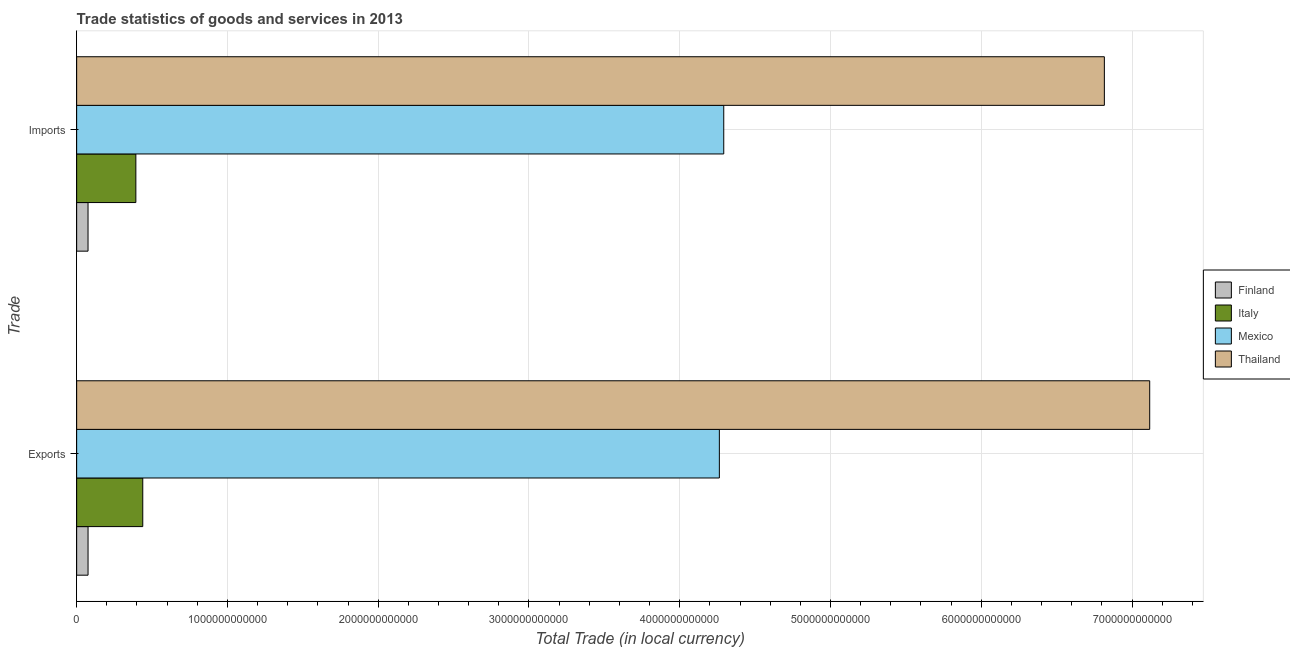How many groups of bars are there?
Make the answer very short. 2. Are the number of bars per tick equal to the number of legend labels?
Offer a terse response. Yes. Are the number of bars on each tick of the Y-axis equal?
Give a very brief answer. Yes. How many bars are there on the 2nd tick from the bottom?
Give a very brief answer. 4. What is the label of the 1st group of bars from the top?
Keep it short and to the point. Imports. What is the export of goods and services in Italy?
Your response must be concise. 4.38e+11. Across all countries, what is the maximum imports of goods and services?
Your response must be concise. 6.82e+12. Across all countries, what is the minimum export of goods and services?
Keep it short and to the point. 7.56e+1. In which country was the imports of goods and services maximum?
Your answer should be very brief. Thailand. What is the total export of goods and services in the graph?
Your answer should be very brief. 1.19e+13. What is the difference between the export of goods and services in Mexico and that in Finland?
Keep it short and to the point. 4.19e+12. What is the difference between the imports of goods and services in Finland and the export of goods and services in Italy?
Offer a terse response. -3.63e+11. What is the average imports of goods and services per country?
Your response must be concise. 2.89e+12. What is the difference between the imports of goods and services and export of goods and services in Italy?
Provide a short and direct response. -4.58e+1. What is the ratio of the export of goods and services in Mexico to that in Italy?
Make the answer very short. 9.72. Is the export of goods and services in Italy less than that in Mexico?
Your answer should be compact. Yes. In how many countries, is the imports of goods and services greater than the average imports of goods and services taken over all countries?
Offer a terse response. 2. What does the 3rd bar from the top in Imports represents?
Make the answer very short. Italy. What does the 3rd bar from the bottom in Exports represents?
Keep it short and to the point. Mexico. How many bars are there?
Give a very brief answer. 8. How many countries are there in the graph?
Keep it short and to the point. 4. What is the difference between two consecutive major ticks on the X-axis?
Your answer should be very brief. 1.00e+12. How many legend labels are there?
Offer a terse response. 4. What is the title of the graph?
Your answer should be compact. Trade statistics of goods and services in 2013. What is the label or title of the X-axis?
Your answer should be very brief. Total Trade (in local currency). What is the label or title of the Y-axis?
Offer a very short reply. Trade. What is the Total Trade (in local currency) of Finland in Exports?
Your answer should be very brief. 7.56e+1. What is the Total Trade (in local currency) in Italy in Exports?
Make the answer very short. 4.38e+11. What is the Total Trade (in local currency) in Mexico in Exports?
Ensure brevity in your answer.  4.26e+12. What is the Total Trade (in local currency) of Thailand in Exports?
Provide a short and direct response. 7.12e+12. What is the Total Trade (in local currency) of Finland in Imports?
Your response must be concise. 7.55e+1. What is the Total Trade (in local currency) of Italy in Imports?
Offer a very short reply. 3.93e+11. What is the Total Trade (in local currency) of Mexico in Imports?
Your response must be concise. 4.29e+12. What is the Total Trade (in local currency) of Thailand in Imports?
Your answer should be very brief. 6.82e+12. Across all Trade, what is the maximum Total Trade (in local currency) in Finland?
Your answer should be very brief. 7.56e+1. Across all Trade, what is the maximum Total Trade (in local currency) in Italy?
Your answer should be very brief. 4.38e+11. Across all Trade, what is the maximum Total Trade (in local currency) in Mexico?
Ensure brevity in your answer.  4.29e+12. Across all Trade, what is the maximum Total Trade (in local currency) in Thailand?
Keep it short and to the point. 7.12e+12. Across all Trade, what is the minimum Total Trade (in local currency) of Finland?
Provide a succinct answer. 7.55e+1. Across all Trade, what is the minimum Total Trade (in local currency) in Italy?
Your response must be concise. 3.93e+11. Across all Trade, what is the minimum Total Trade (in local currency) of Mexico?
Make the answer very short. 4.26e+12. Across all Trade, what is the minimum Total Trade (in local currency) in Thailand?
Offer a very short reply. 6.82e+12. What is the total Total Trade (in local currency) of Finland in the graph?
Provide a succinct answer. 1.51e+11. What is the total Total Trade (in local currency) in Italy in the graph?
Offer a very short reply. 8.31e+11. What is the total Total Trade (in local currency) of Mexico in the graph?
Offer a very short reply. 8.55e+12. What is the total Total Trade (in local currency) of Thailand in the graph?
Make the answer very short. 1.39e+13. What is the difference between the Total Trade (in local currency) in Finland in Exports and that in Imports?
Offer a terse response. 1.14e+08. What is the difference between the Total Trade (in local currency) in Italy in Exports and that in Imports?
Keep it short and to the point. 4.58e+1. What is the difference between the Total Trade (in local currency) in Mexico in Exports and that in Imports?
Offer a terse response. -2.92e+1. What is the difference between the Total Trade (in local currency) of Thailand in Exports and that in Imports?
Make the answer very short. 3.01e+11. What is the difference between the Total Trade (in local currency) of Finland in Exports and the Total Trade (in local currency) of Italy in Imports?
Provide a succinct answer. -3.17e+11. What is the difference between the Total Trade (in local currency) of Finland in Exports and the Total Trade (in local currency) of Mexico in Imports?
Offer a terse response. -4.22e+12. What is the difference between the Total Trade (in local currency) of Finland in Exports and the Total Trade (in local currency) of Thailand in Imports?
Ensure brevity in your answer.  -6.74e+12. What is the difference between the Total Trade (in local currency) of Italy in Exports and the Total Trade (in local currency) of Mexico in Imports?
Keep it short and to the point. -3.85e+12. What is the difference between the Total Trade (in local currency) of Italy in Exports and the Total Trade (in local currency) of Thailand in Imports?
Your response must be concise. -6.38e+12. What is the difference between the Total Trade (in local currency) in Mexico in Exports and the Total Trade (in local currency) in Thailand in Imports?
Your answer should be very brief. -2.55e+12. What is the average Total Trade (in local currency) of Finland per Trade?
Your response must be concise. 7.55e+1. What is the average Total Trade (in local currency) in Italy per Trade?
Offer a terse response. 4.16e+11. What is the average Total Trade (in local currency) of Mexico per Trade?
Provide a succinct answer. 4.28e+12. What is the average Total Trade (in local currency) of Thailand per Trade?
Provide a short and direct response. 6.97e+12. What is the difference between the Total Trade (in local currency) of Finland and Total Trade (in local currency) of Italy in Exports?
Ensure brevity in your answer.  -3.63e+11. What is the difference between the Total Trade (in local currency) in Finland and Total Trade (in local currency) in Mexico in Exports?
Your response must be concise. -4.19e+12. What is the difference between the Total Trade (in local currency) of Finland and Total Trade (in local currency) of Thailand in Exports?
Make the answer very short. -7.04e+12. What is the difference between the Total Trade (in local currency) of Italy and Total Trade (in local currency) of Mexico in Exports?
Offer a very short reply. -3.82e+12. What is the difference between the Total Trade (in local currency) of Italy and Total Trade (in local currency) of Thailand in Exports?
Provide a short and direct response. -6.68e+12. What is the difference between the Total Trade (in local currency) in Mexico and Total Trade (in local currency) in Thailand in Exports?
Offer a terse response. -2.85e+12. What is the difference between the Total Trade (in local currency) of Finland and Total Trade (in local currency) of Italy in Imports?
Offer a very short reply. -3.17e+11. What is the difference between the Total Trade (in local currency) in Finland and Total Trade (in local currency) in Mexico in Imports?
Make the answer very short. -4.22e+12. What is the difference between the Total Trade (in local currency) of Finland and Total Trade (in local currency) of Thailand in Imports?
Keep it short and to the point. -6.74e+12. What is the difference between the Total Trade (in local currency) of Italy and Total Trade (in local currency) of Mexico in Imports?
Your answer should be very brief. -3.90e+12. What is the difference between the Total Trade (in local currency) in Italy and Total Trade (in local currency) in Thailand in Imports?
Offer a terse response. -6.42e+12. What is the difference between the Total Trade (in local currency) of Mexico and Total Trade (in local currency) of Thailand in Imports?
Give a very brief answer. -2.52e+12. What is the ratio of the Total Trade (in local currency) of Italy in Exports to that in Imports?
Your answer should be very brief. 1.12. What is the ratio of the Total Trade (in local currency) of Mexico in Exports to that in Imports?
Offer a terse response. 0.99. What is the ratio of the Total Trade (in local currency) of Thailand in Exports to that in Imports?
Make the answer very short. 1.04. What is the difference between the highest and the second highest Total Trade (in local currency) in Finland?
Your answer should be compact. 1.14e+08. What is the difference between the highest and the second highest Total Trade (in local currency) in Italy?
Ensure brevity in your answer.  4.58e+1. What is the difference between the highest and the second highest Total Trade (in local currency) in Mexico?
Provide a succinct answer. 2.92e+1. What is the difference between the highest and the second highest Total Trade (in local currency) in Thailand?
Offer a very short reply. 3.01e+11. What is the difference between the highest and the lowest Total Trade (in local currency) in Finland?
Your answer should be compact. 1.14e+08. What is the difference between the highest and the lowest Total Trade (in local currency) of Italy?
Give a very brief answer. 4.58e+1. What is the difference between the highest and the lowest Total Trade (in local currency) in Mexico?
Offer a very short reply. 2.92e+1. What is the difference between the highest and the lowest Total Trade (in local currency) of Thailand?
Your response must be concise. 3.01e+11. 